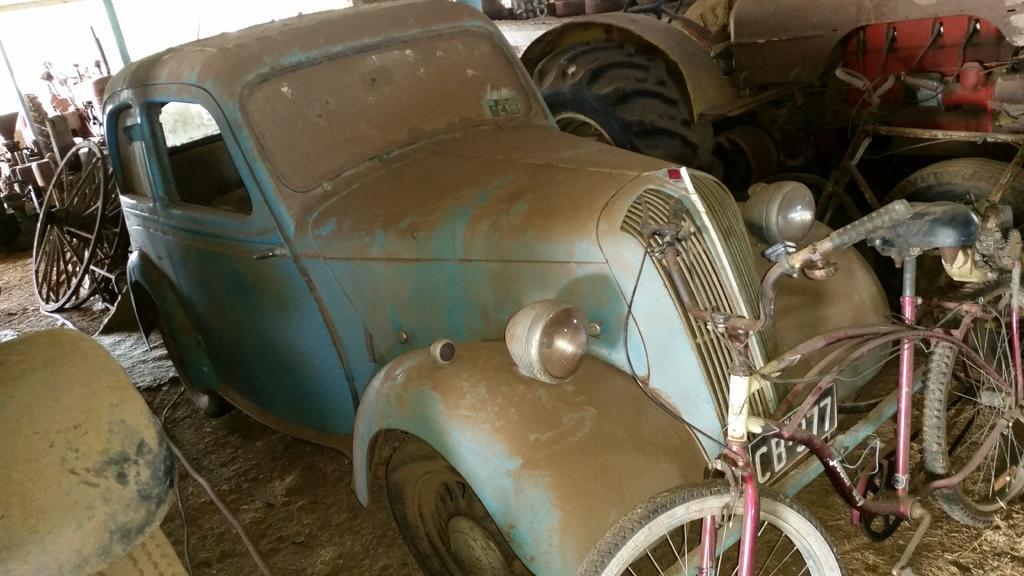Can you describe this image briefly? In this image I can see a car which is blue and brown in color on the ground. To the left bottom of the image I can see an object which is brown and black in color on the ground. I can see a bicycle and few other old vehicles on the ground. In the background I can see the wheel and few other objects. 